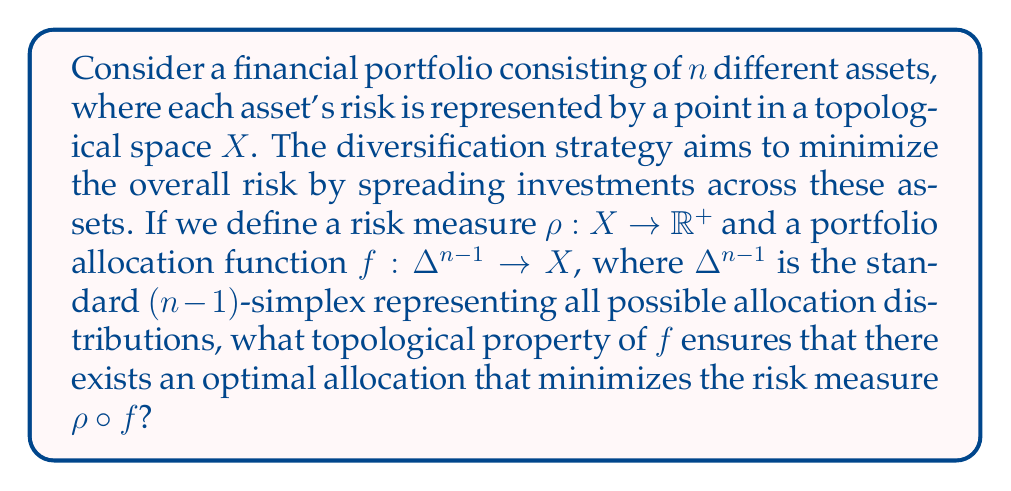Solve this math problem. To solve this problem, we need to consider the topological properties of the spaces involved and the functions defined on them:

1. The risk space $X$ is a topological space representing all possible risk profiles.
2. The risk measure $\rho: X \to \mathbb{R}^+$ maps risk profiles to non-negative real numbers.
3. The standard $(n-1)$-simplex $\Delta^{n-1}$ represents all possible allocation distributions across $n$ assets.
4. The portfolio allocation function $f: \Delta^{n-1} \to X$ maps allocation distributions to risk profiles.

The composition $\rho \circ f: \Delta^{n-1} \to \mathbb{R}^+$ represents the overall risk of the portfolio for a given allocation.

To ensure the existence of an optimal allocation that minimizes the risk measure, we need the function $\rho \circ f$ to attain its minimum value on $\Delta^{n-1}$. The key topological property that guarantees this is continuity.

If $f$ is continuous, and $\rho$ is also continuous (which is a reasonable assumption for a risk measure), then their composition $\rho \circ f$ is continuous.

Now, we can apply the extreme value theorem from topology:

Extreme Value Theorem: If a real-valued function is continuous on a compact set, it attains its maximum and minimum values on that set.

The standard $(n-1)$-simplex $\Delta^{n-1}$ is a compact set in $\mathbb{R}^n$. Therefore, if $\rho \circ f$ is continuous, it will attain its minimum value on $\Delta^{n-1}$, ensuring the existence of an optimal allocation that minimizes the risk measure.

Thus, the crucial topological property of $f$ that ensures the existence of an optimal allocation is continuity.
Answer: The topological property of $f$ that ensures the existence of an optimal allocation minimizing the risk measure $\rho \circ f$ is continuity. 